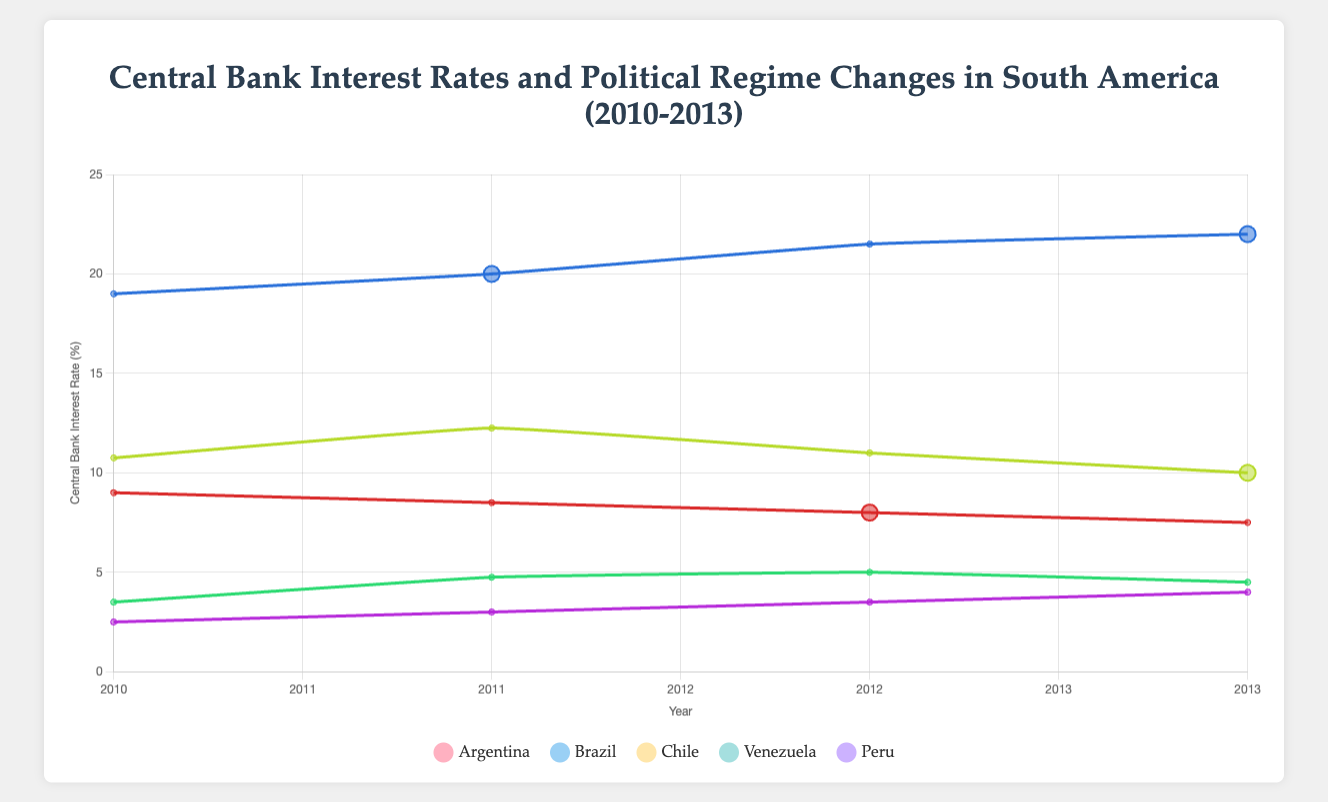What trend in Central Bank Interest Rates do you observe for Argentina from 2010 to 2013? Observing the line for Argentina, it starts at 9.0% in 2010 and gradually decreases each year, ending at 7.5% in 2013.
Answer: Decreasing trend Which country had the highest Central Bank Interest Rate in 2010? Looking at the data points for 2010, Venezuela's point is the highest on the y-axis at 19.0%.
Answer: Venezuela In which year did Brazil experience a Political Regime Change, and what was the Central Bank Interest Rate that year? For Brazil, the larger, black-colored data point indicates a regime change in 2013 with a Central Bank Interest Rate of 10.0%.
Answer: 2013, 10.0% Comparing Chile and Peru, which country had a higher Central Bank Interest Rate in 2012? Chile’s point in 2012 is higher on the y-axis at 5.0%, compared to Peru's 3.5%.
Answer: Chile What is the difference in Central Bank Interest Rates between Venezuela and Argentina in 2013? Venezuela's interest rate in 2013 is 22.0%, and Argentina's is 7.5%. The difference is 22.0% - 7.5% = 14.5%.
Answer: 14.5% How many Political Regime Changes occurred in the dataset between 2010 and 2013? Counting all the larger, black-colored data points, there are five regime changes (one each for Argentina in 2012, Brazil in 2013, Venezuela in 2011, and Venezuela again in 2013).
Answer: 5 What is the average Central Bank Interest Rate for Peru from 2010 to 2013? The rates are 2.5%, 3.0%, 3.5%, and 4.0%. The sum is 2.5 + 3.0 + 3.5 + 4.0 = 13.0. Dividing by 4 years, the average is 13.0 / 4 = 3.25%.
Answer: 3.25% Which two countries had no Political Regime Changes from 2010 to 2013? Observing the plot, Chile and Peru do not have any larger, black-colored data points, indicating no regime changes.
Answer: Chile, Peru 